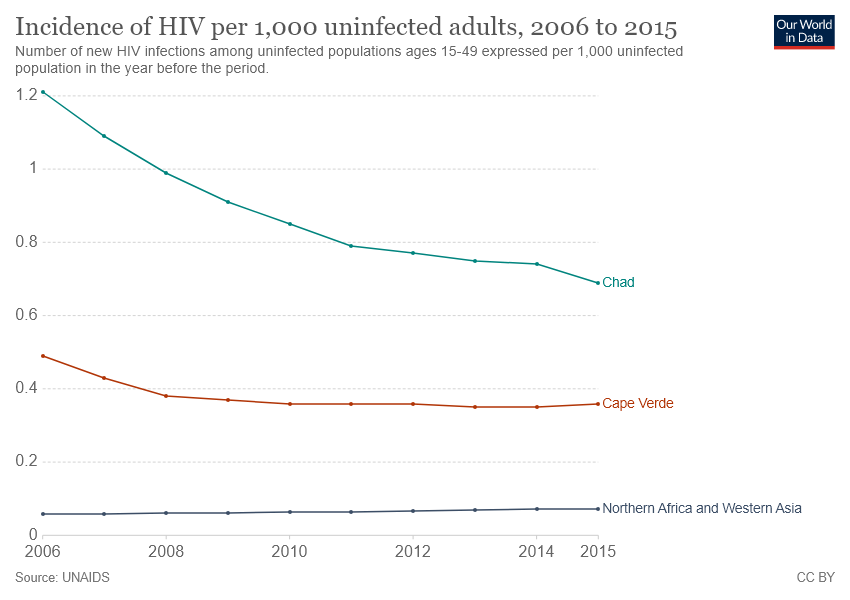List a handful of essential elements in this visual. Cape Verde is represented by the red color line in a country. In 2006, the highest number of reported cases of HIV were recorded in Chad. 